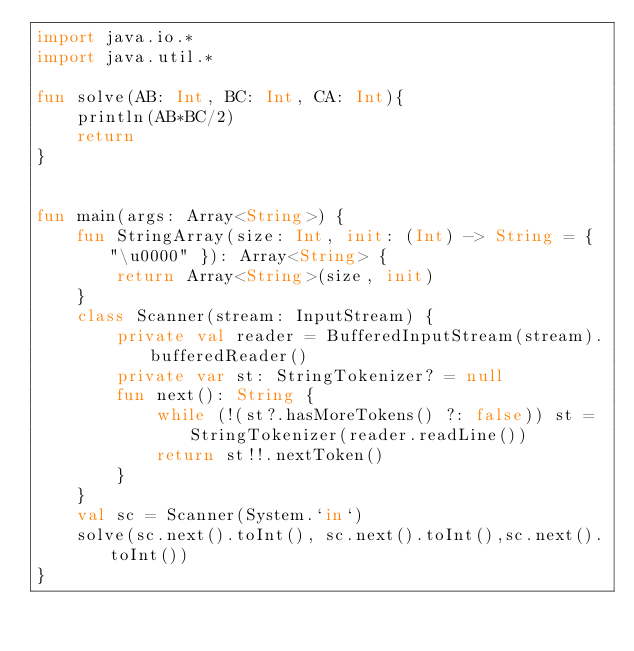<code> <loc_0><loc_0><loc_500><loc_500><_Kotlin_>import java.io.*
import java.util.*

fun solve(AB: Int, BC: Int, CA: Int){
    println(AB*BC/2)
    return
}


fun main(args: Array<String>) {
    fun StringArray(size: Int, init: (Int) -> String = { "\u0000" }): Array<String> {
        return Array<String>(size, init)
    }
    class Scanner(stream: InputStream) {
        private val reader = BufferedInputStream(stream).bufferedReader()
        private var st: StringTokenizer? = null
        fun next(): String {
            while (!(st?.hasMoreTokens() ?: false)) st = StringTokenizer(reader.readLine())
            return st!!.nextToken()
        }
    }
    val sc = Scanner(System.`in`)
    solve(sc.next().toInt(), sc.next().toInt(),sc.next().toInt())
}

</code> 